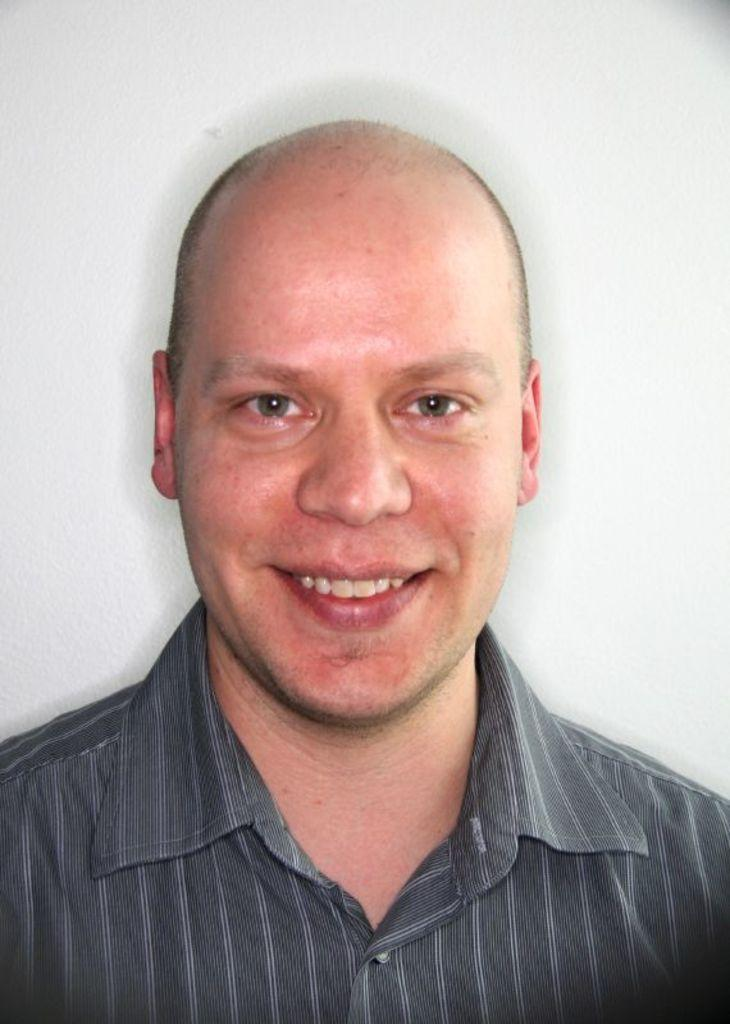What is the color of the wall in the image? The wall in the image is white. Who is present in the image? There is a man in the image. What is the man wearing? The man is wearing a black color shirt. Can you see any pigs grazing on the grass in the image? There is no grass or pig present in the image. What type of glove is the man wearing in the image? The man is not wearing a glove in the image; he is wearing a black color shirt. 